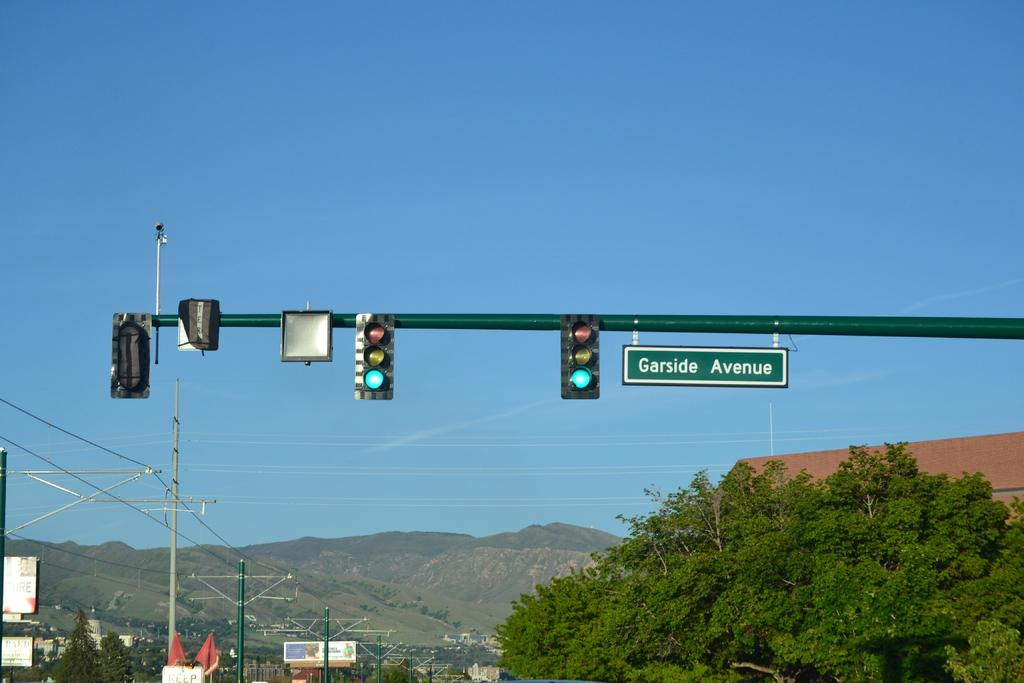Provide a one-sentence caption for the provided image. Before you get to the mountains, there's a set of traffic lights at Garside Avenue. 